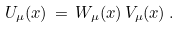<formula> <loc_0><loc_0><loc_500><loc_500>U _ { \mu } ( x ) \, = \, W _ { \mu } ( x ) \, V _ { \mu } ( x ) \, .</formula> 